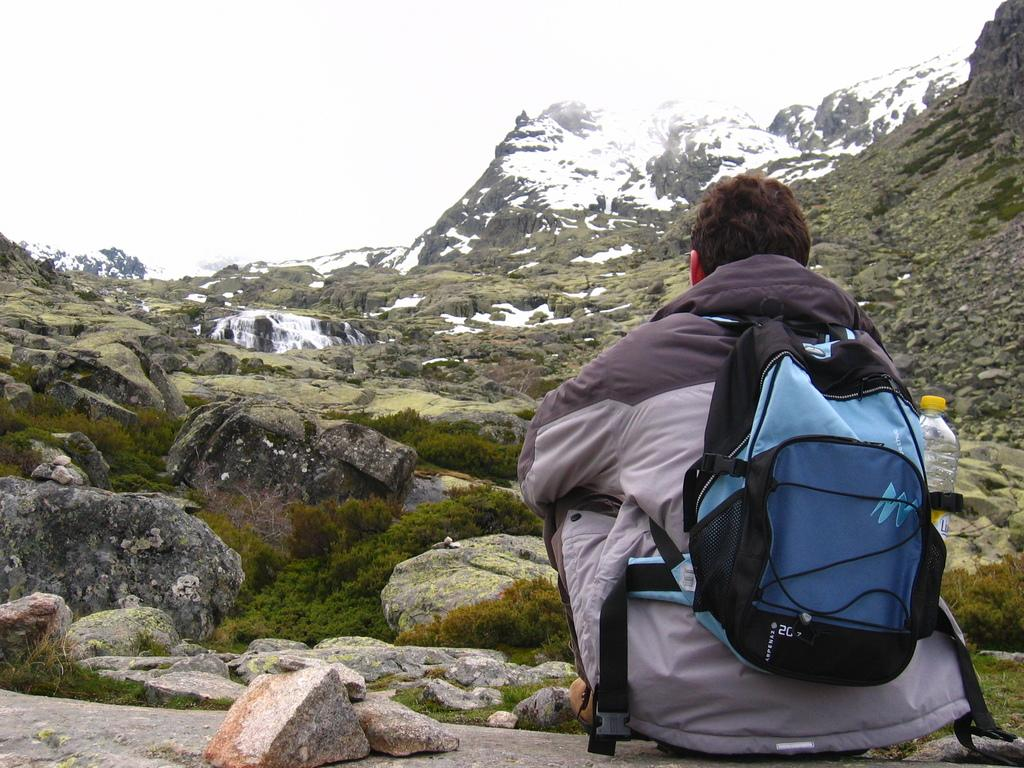What type of jacket is the person wearing in the image? The person is wearing a black and white jacket. What is the person carrying on his back? The person is carrying a blue bag on his back. Where is the person sitting in the image? The person is sitting on a rock. What can be seen in the background of the image? There are green mountains and snow-capped mountains visible in the image. What statement does the person make about society in the image? There is no statement made by the person about society in the image. What is the chance of the person encountering a wild animal in the image? There is no indication of the presence of wild animals in the image, so it is impossible to determine the chance of encountering one. 